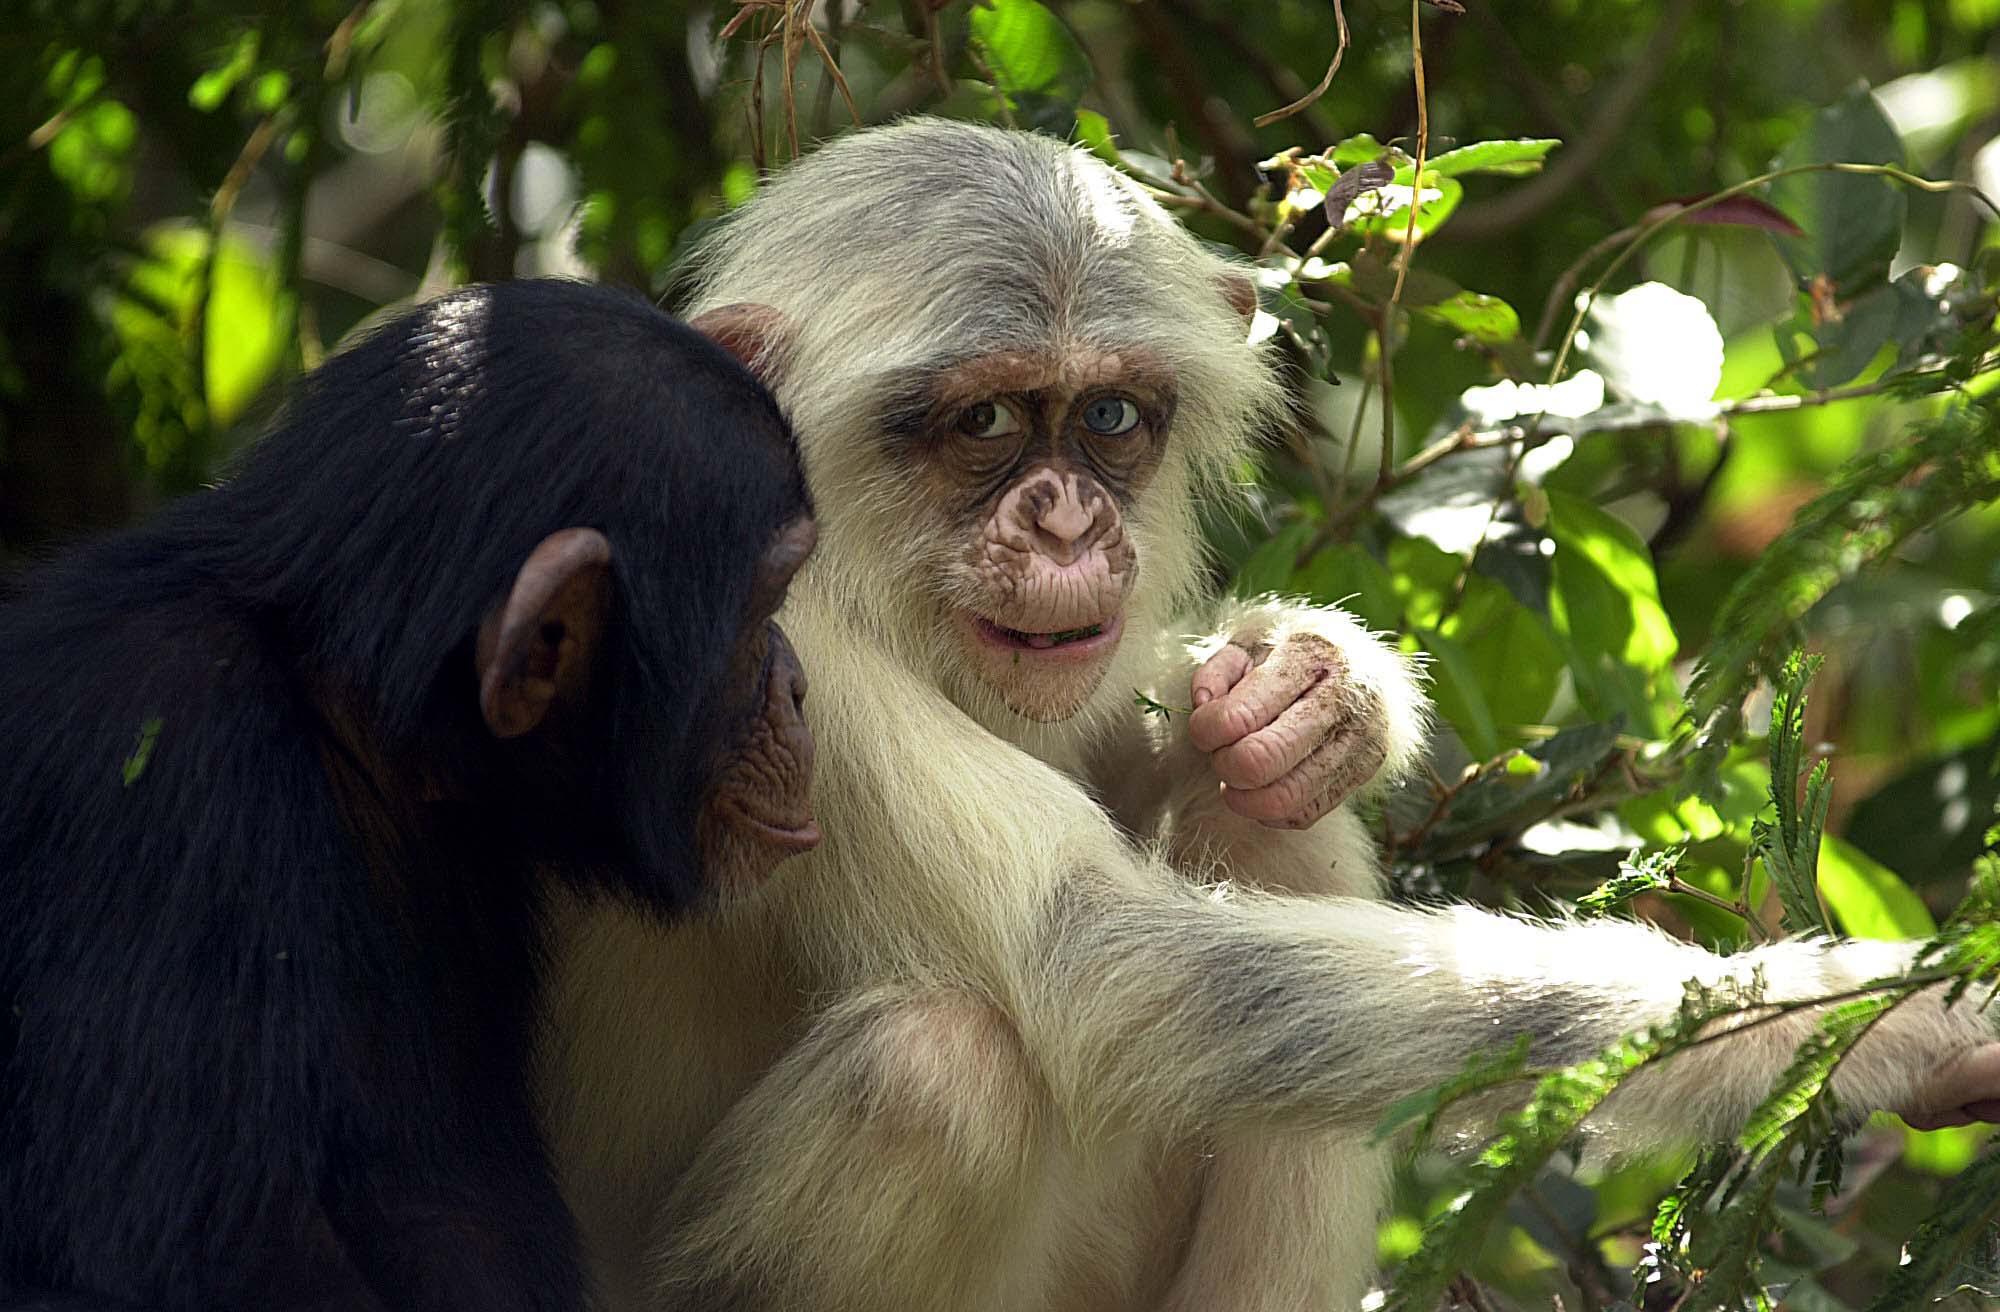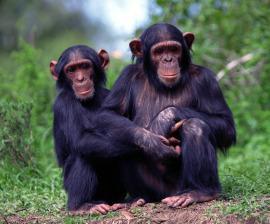The first image is the image on the left, the second image is the image on the right. Analyze the images presented: Is the assertion "There is more than one chimp in every single image." valid? Answer yes or no. Yes. The first image is the image on the left, the second image is the image on the right. Given the left and right images, does the statement "There are at least two chimpanzees in each image." hold true? Answer yes or no. Yes. 